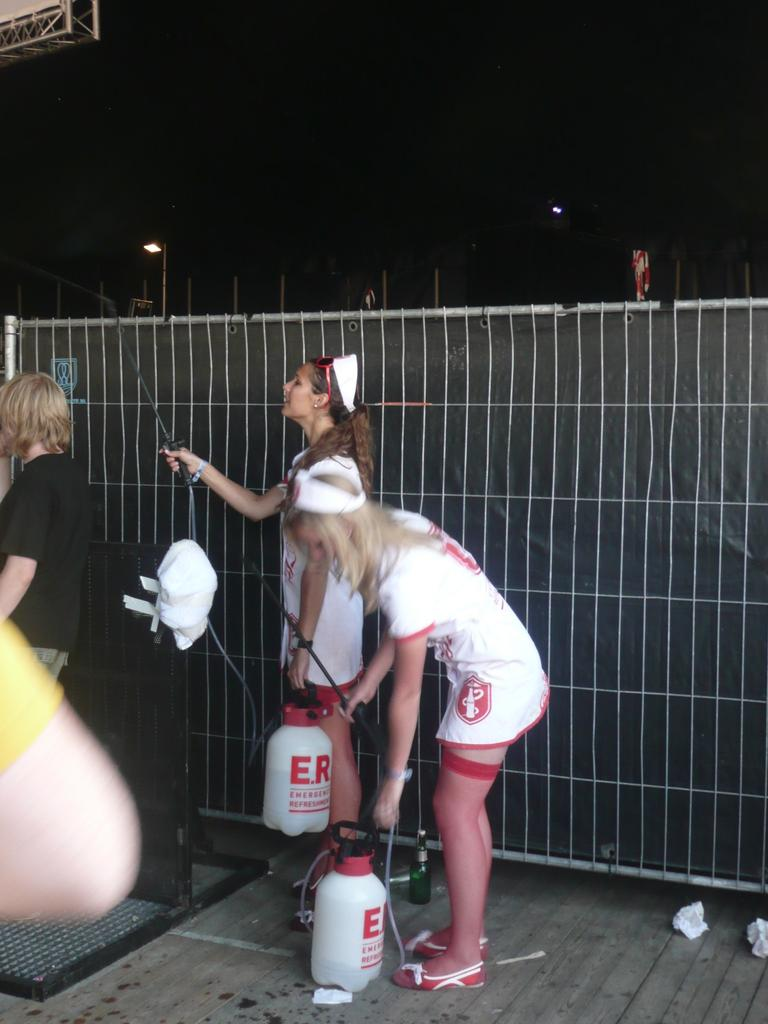<image>
Create a compact narrative representing the image presented. Two women dressed up like nurses carry bottles marked E.R. 